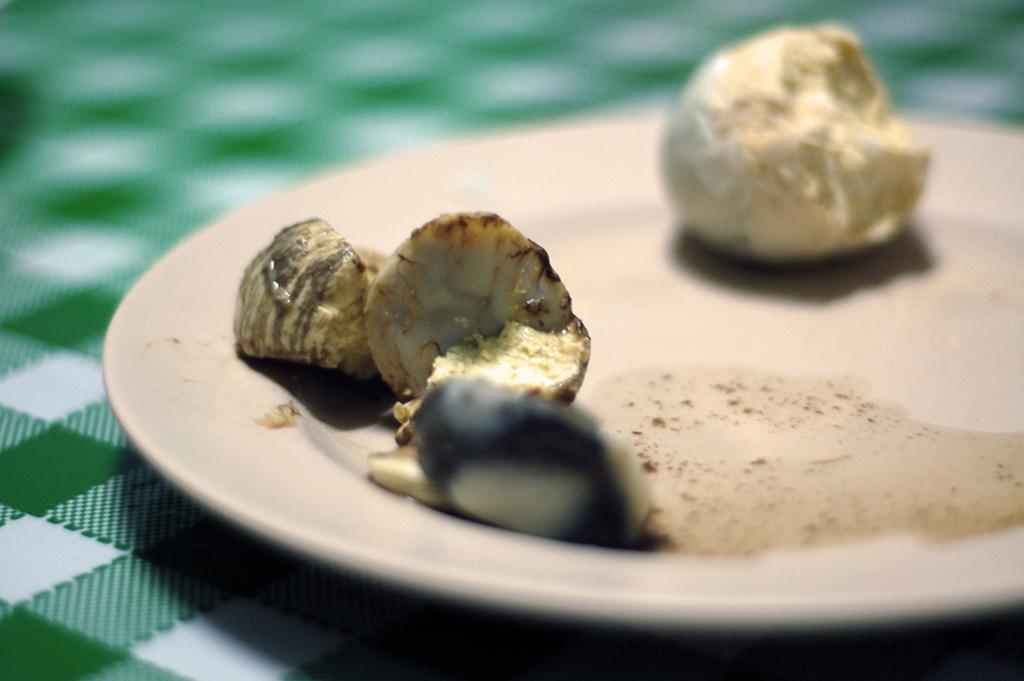How would you summarize this image in a sentence or two? In this image there is a table, on that table there is a plate in that place there is food item. 